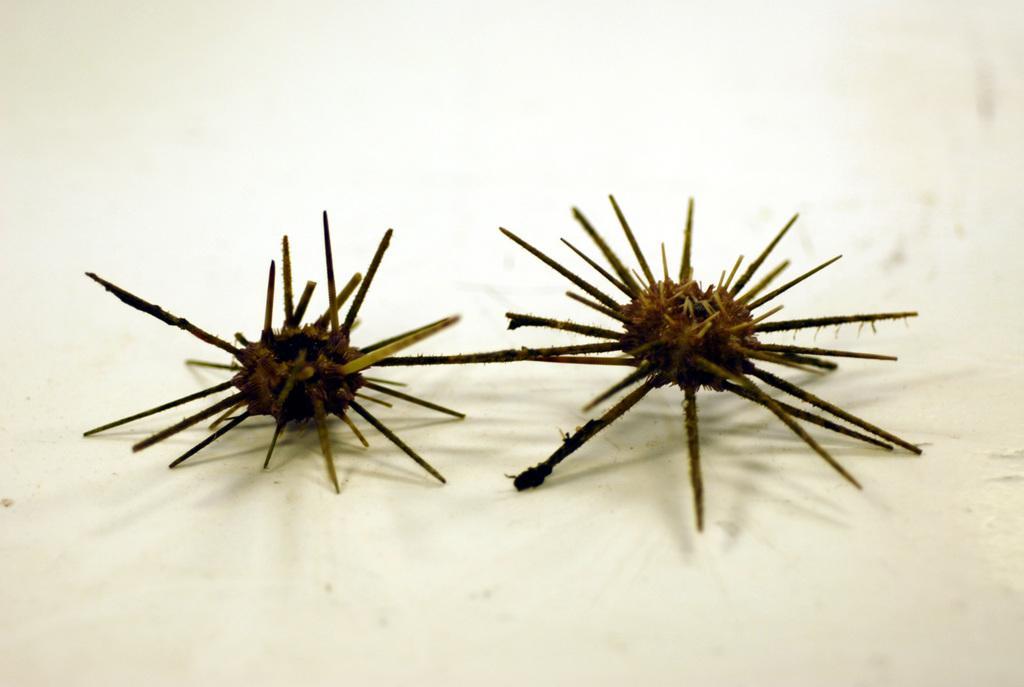Could you give a brief overview of what you see in this image? In this image in the center there are some objects, at the bottom there is a wall. 